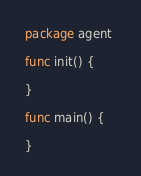<code> <loc_0><loc_0><loc_500><loc_500><_Go_>package agent 

func init() {

}

func main() {

}
</code> 